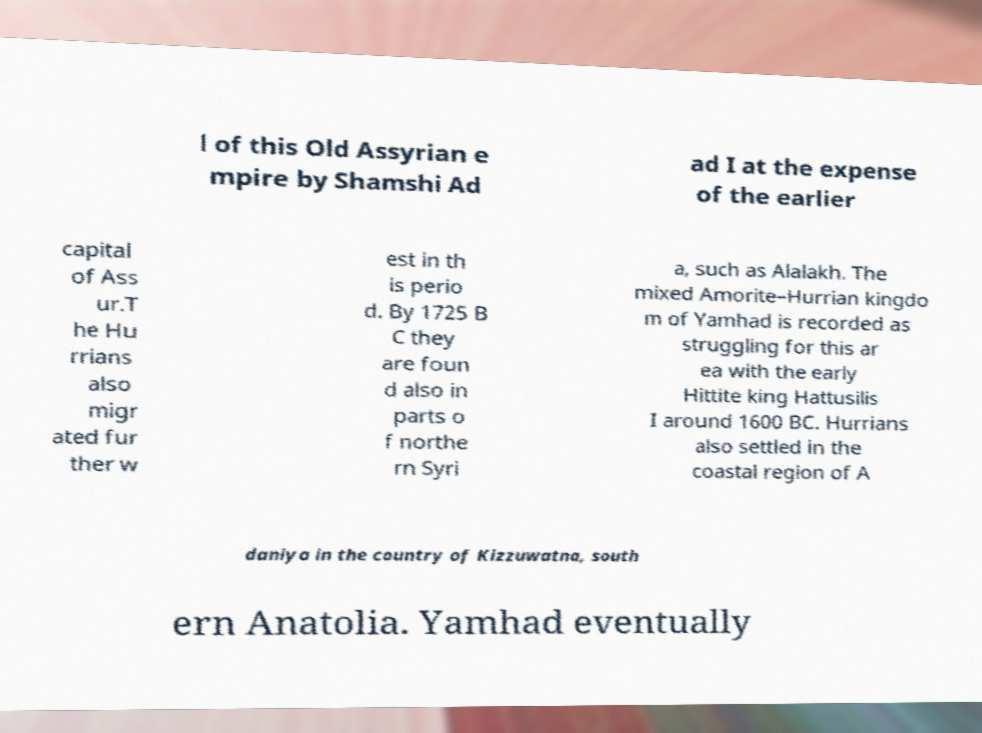Could you assist in decoding the text presented in this image and type it out clearly? l of this Old Assyrian e mpire by Shamshi Ad ad I at the expense of the earlier capital of Ass ur.T he Hu rrians also migr ated fur ther w est in th is perio d. By 1725 B C they are foun d also in parts o f northe rn Syri a, such as Alalakh. The mixed Amorite–Hurrian kingdo m of Yamhad is recorded as struggling for this ar ea with the early Hittite king Hattusilis I around 1600 BC. Hurrians also settled in the coastal region of A daniya in the country of Kizzuwatna, south ern Anatolia. Yamhad eventually 